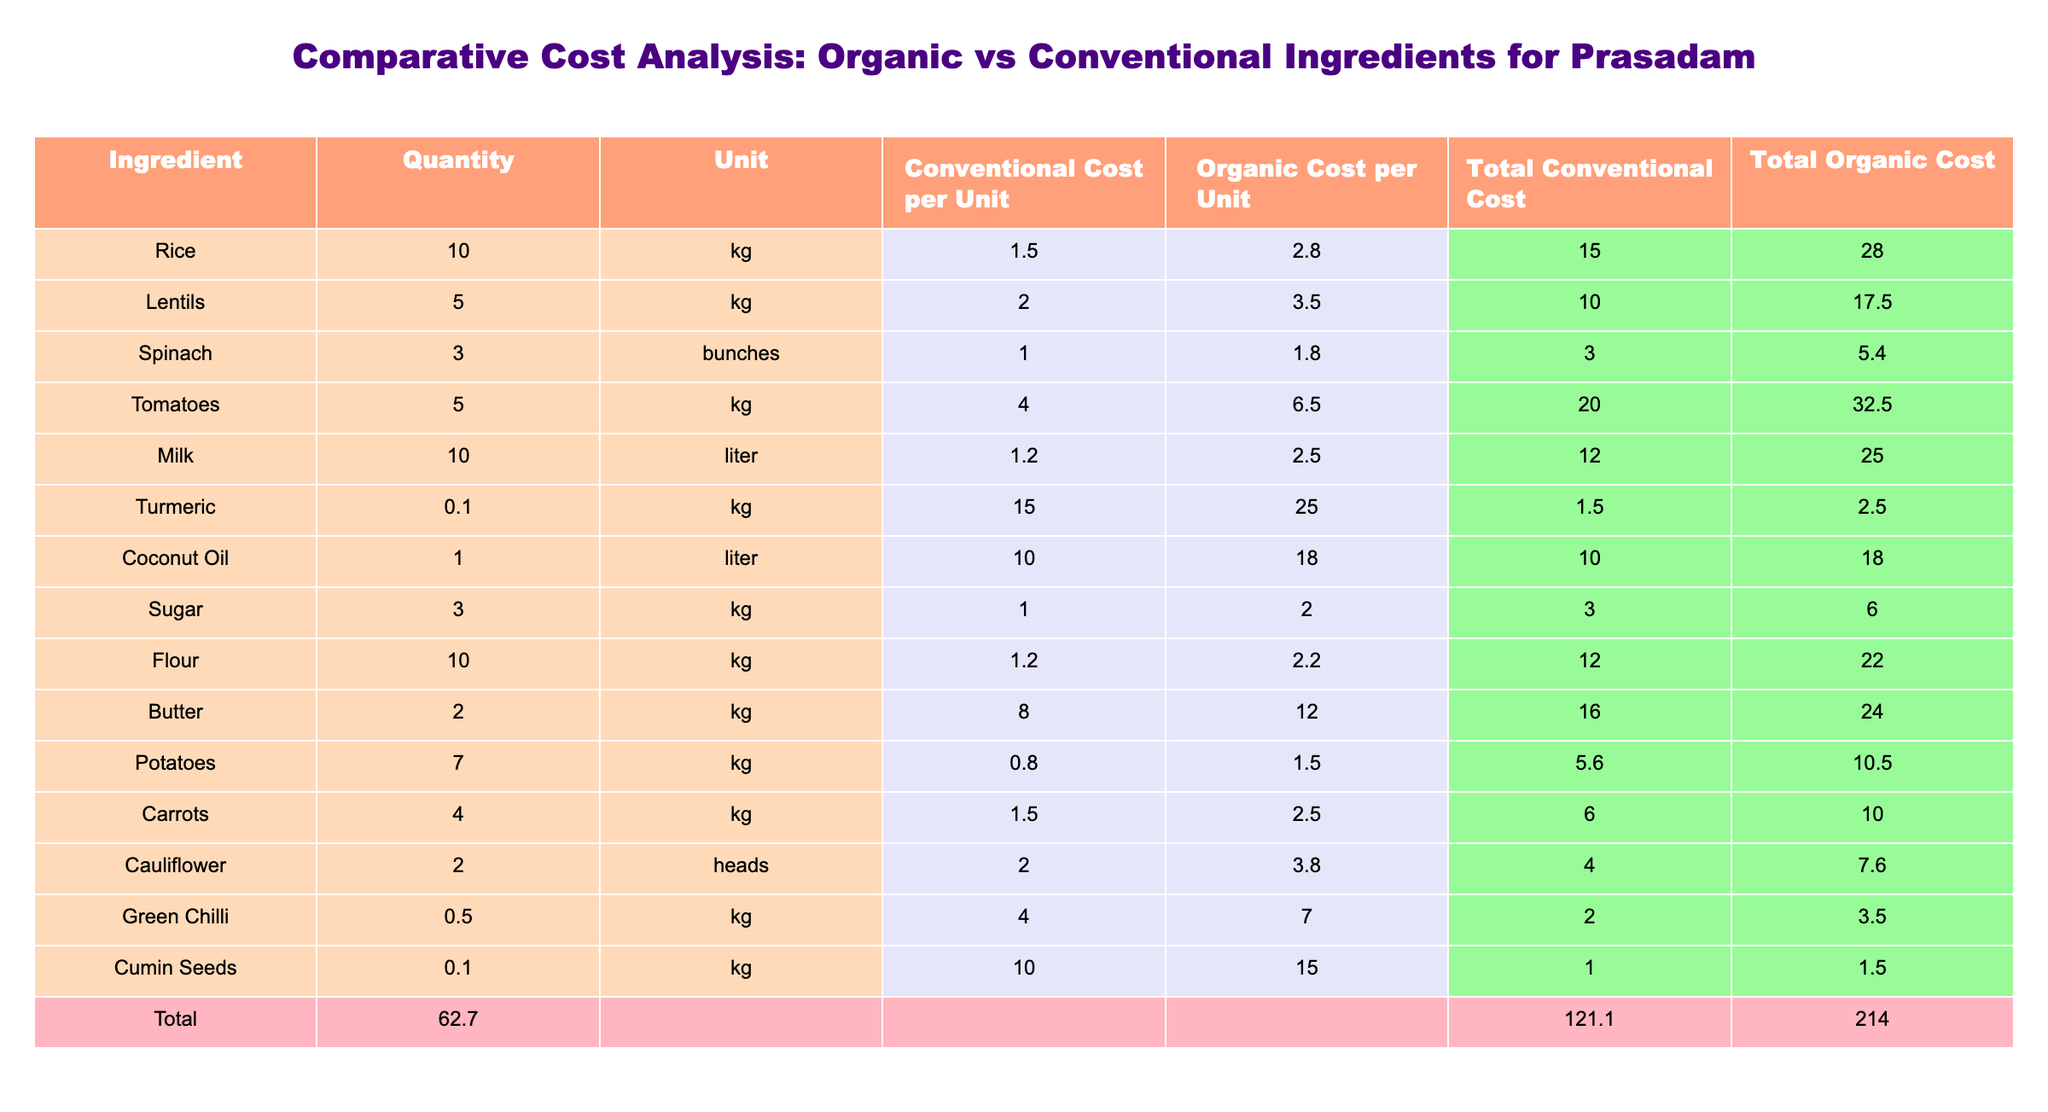What is the total conventional cost for all ingredients? To find the total conventional cost, you sum the "Total Conventional Cost" column: 15.00 + 10.00 + 3.00 + 20.00 + 12.00 + 1.50 + 10.00 + 3.00 + 12.00 + 16.00 + 5.60 + 6.00 + 4.00 + 2.00 + 1.00 = 104.10
Answer: 104.10 What is the cost difference for milk between organic and conventional? The organic cost for milk is 2.50 per liter and the conventional cost is 1.20 per liter. To find the difference, subtract the conventional cost from the organic cost: 2.50 - 1.20 = 1.30
Answer: 1.30 Which ingredient has the highest total organic cost? To find this, you compare the "Total Organic Cost" values for each ingredient. The highest value is for tomatoes, which has a total organic cost of 32.50.
Answer: Tomatoes Is the total organic cost higher than the total conventional cost for all ingredients combined? The total organic cost is 173.50 (sum of the "Total Organic Cost" column), and the total conventional cost is 104.10 (from a previous question). Since 173.50 is greater than 104.10, the statement is true.
Answer: Yes What is the average cost per unit for organic ingredients? To calculate the average organic cost per unit, sum all the "Organic Cost per Unit" values and divide by the number of ingredients (15): (2.80 + 3.50 + 1.80 + 6.50 + 2.50 + 25.00 + 18.00 + 2.00 + 2.20 + 12.00 + 1.50 + 1.50 + 3.80 + 7.00 + 15.00) = 115.60, divide by 15 = 7.71.
Answer: 7.71 What percentage more expensive is the total organic cost compared to the total conventional cost? First, find the total organic cost: 173.50. The total conventional cost is 104.10. The percentage increase is calculated as ((173.50 - 104.10) / 104.10) * 100, which equals approximately 66.67%.
Answer: 66.67% How much would it cost to replace all conventional ingredients with organic ones for rice? The cost of rice per unit is 2.80 for organic. Given the quantity of 10 kg, the total cost would be 10 * 2.80 = 28.00
Answer: 28.00 Are the organic costs for turmeric and cumin seeds both over 20? The organic cost for turmeric is 25.00 and for cumin seeds is 15.00. Since only turmeric exceeds 20, the answer is false.
Answer: No What is the total quantity of all ingredients combined? You add all the quantities in the "Quantity" column: 10 + 5 + 3 + 5 + 10 + 0.1 + 1 + 3 + 10 + 2 + 7 + 4 + 2 + 0.5 + 0.1 = 63.70
Answer: 63.70 